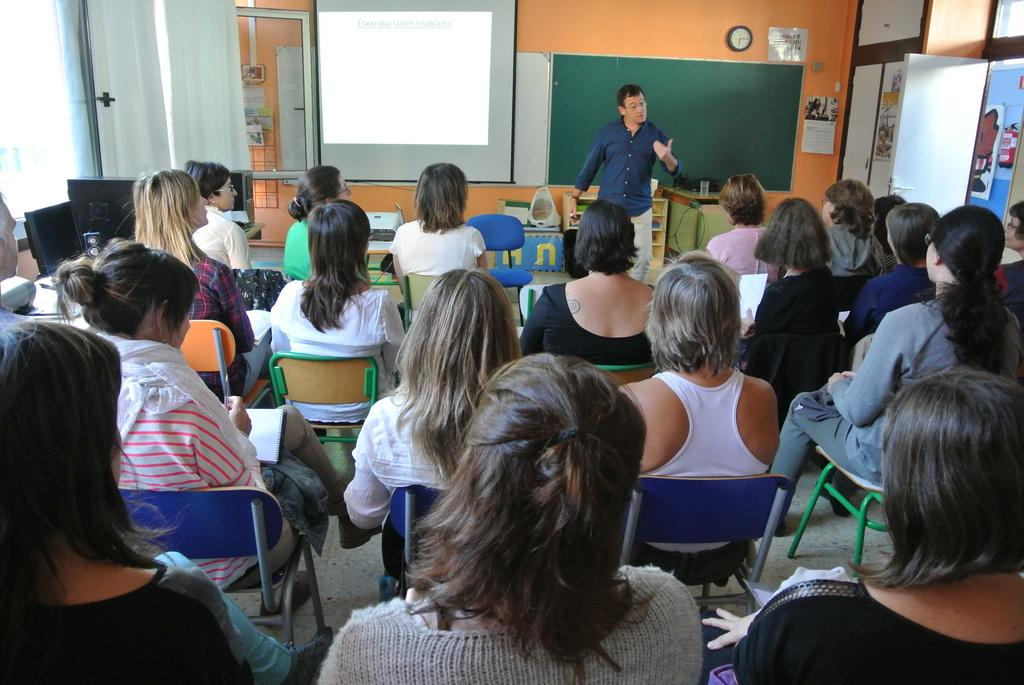What are the people in the image doing? The people in the image are sitting on chairs. What objects can be seen in the image besides the chairs? There are boards, curtains, a clock, posters, and a door in the image. What is the person standing in the image doing? The person standing in the image is not performing any specific action that can be determined from the provided facts. What type of sail can be seen in the image? There is no sail present in the image. What kind of wine is being served in the image? There is no wine present in the image. 